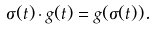<formula> <loc_0><loc_0><loc_500><loc_500>\sigma ( t ) \cdot g ( t ) = g ( \sigma ( t ) ) .</formula> 